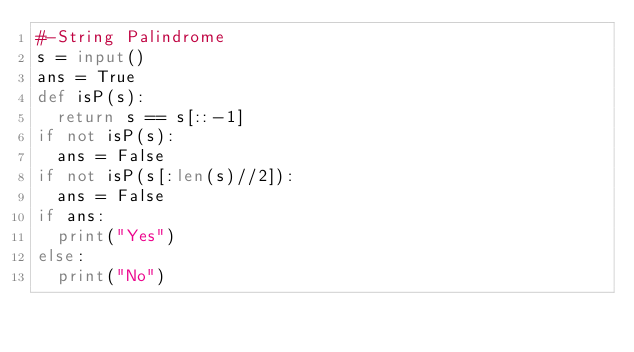Convert code to text. <code><loc_0><loc_0><loc_500><loc_500><_Python_>#-String Palindrome
s = input()
ans = True
def isP(s):
  return s == s[::-1]
if not isP(s):
  ans = False
if not isP(s[:len(s)//2]):
  ans = False
if ans:
  print("Yes")
else:
  print("No")</code> 